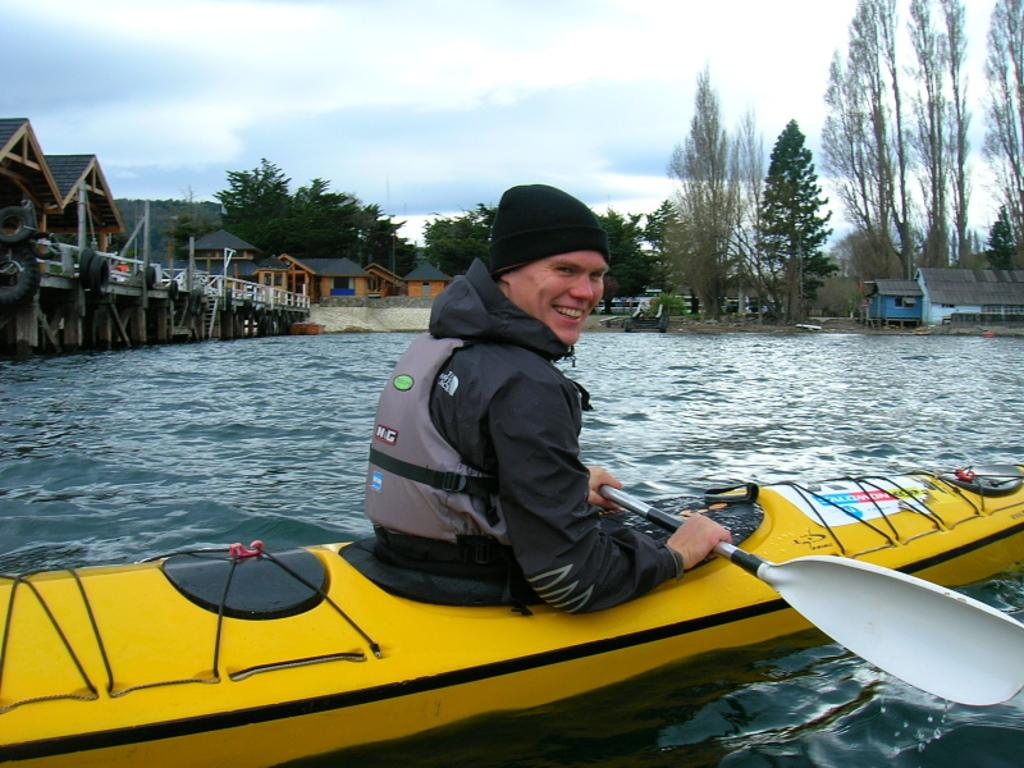What is the man in the image doing? The man is sitting in a boat. What is the man holding in the image? The man is holding a rowing stick. What is visible in the background of the image? There is water, houses, and trees visible in the background of the image. What type of pies can be seen in the image? There are no pies present in the image. What is the man's skin color in the image? The provided facts do not mention the man's skin color, so it cannot be determined from the image. 